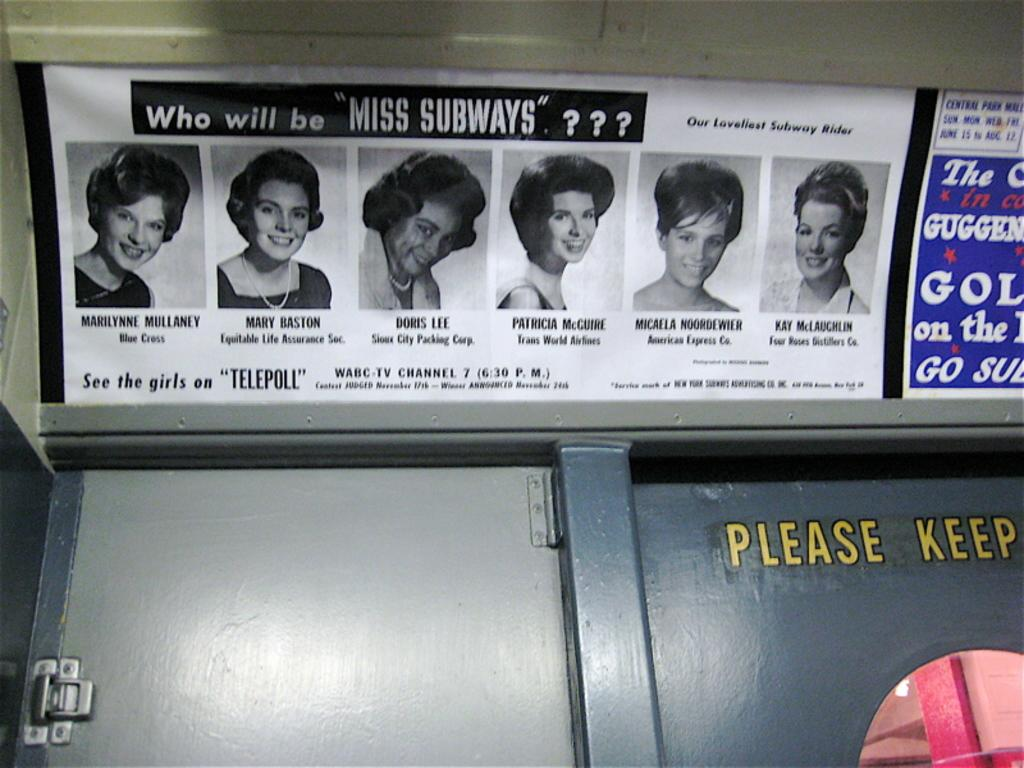What is depicted on the poster in the image? There is a poster with women's pictures and text in the image. Are there any other posters visible in the image? Yes, there is another poster beside the first one. What architectural feature can be seen in the image? There is a door visible in the image. What type of coat is hanging on the door in the image? There is no coat visible in the image; only the door is present. What game is being played on the posters in the image? The posters in the image do not depict any games; they feature women's pictures and text. 